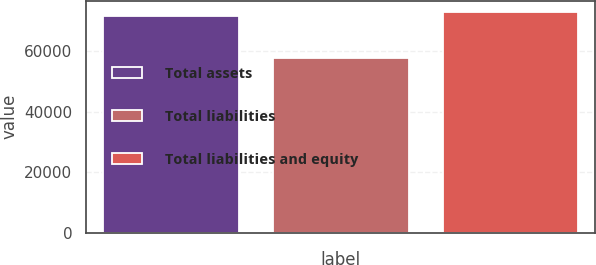<chart> <loc_0><loc_0><loc_500><loc_500><bar_chart><fcel>Total assets<fcel>Total liabilities<fcel>Total liabilities and equity<nl><fcel>71670<fcel>57775<fcel>73059.5<nl></chart> 